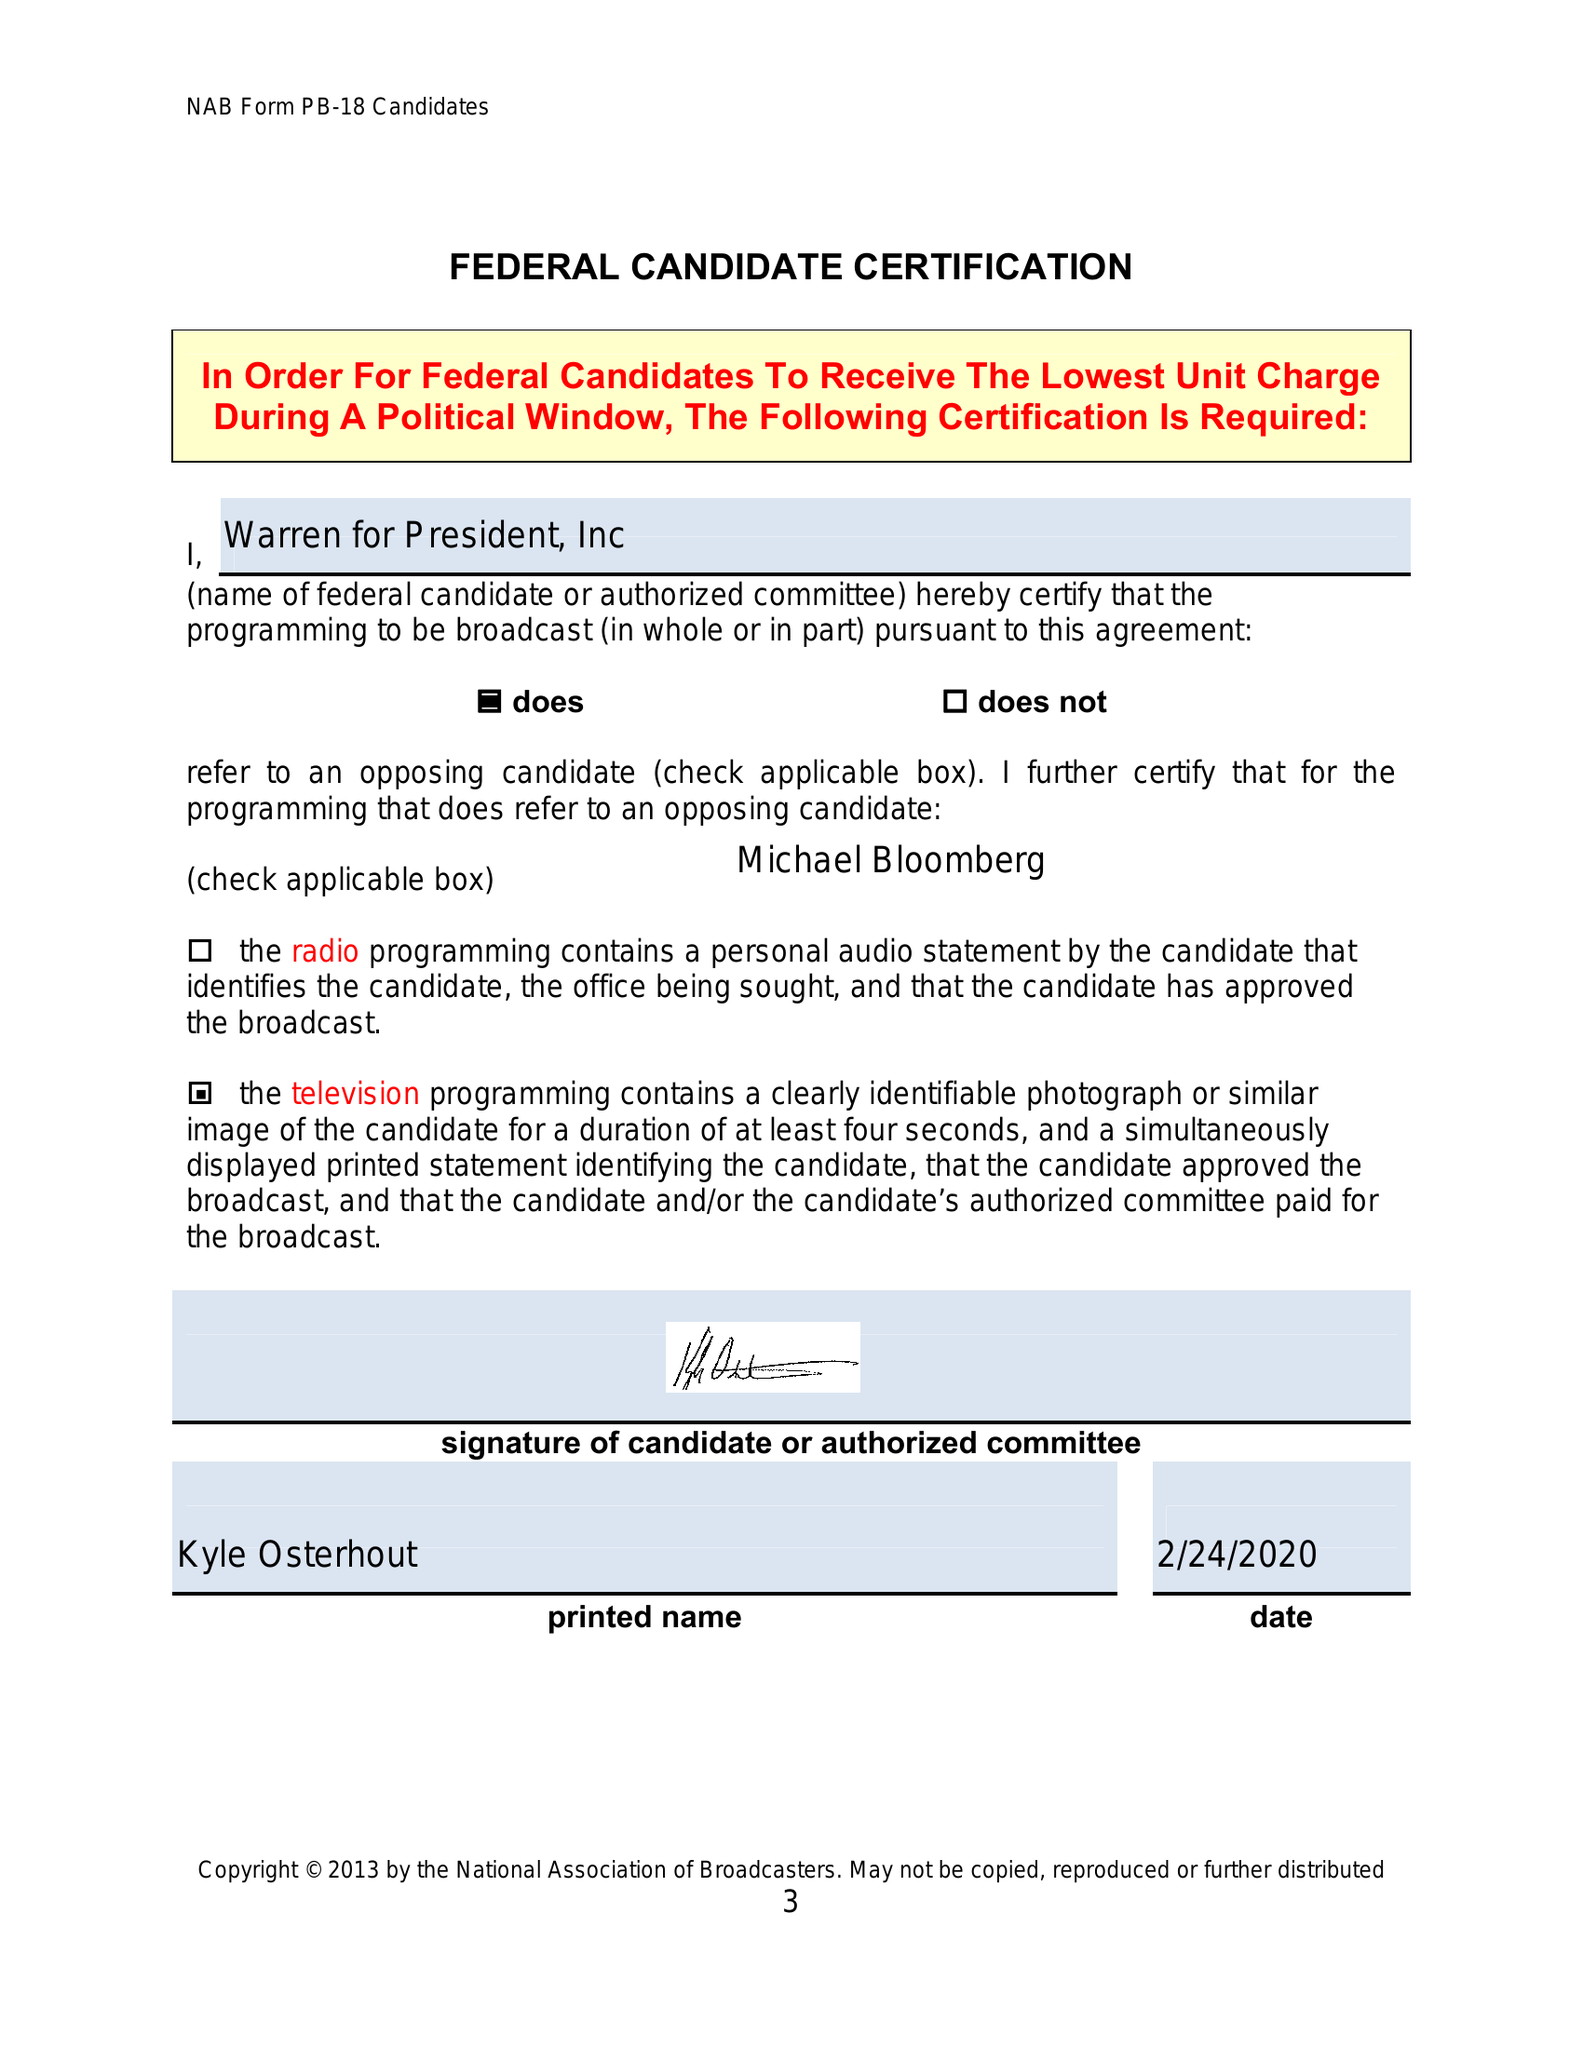What is the value for the gross_amount?
Answer the question using a single word or phrase. None 